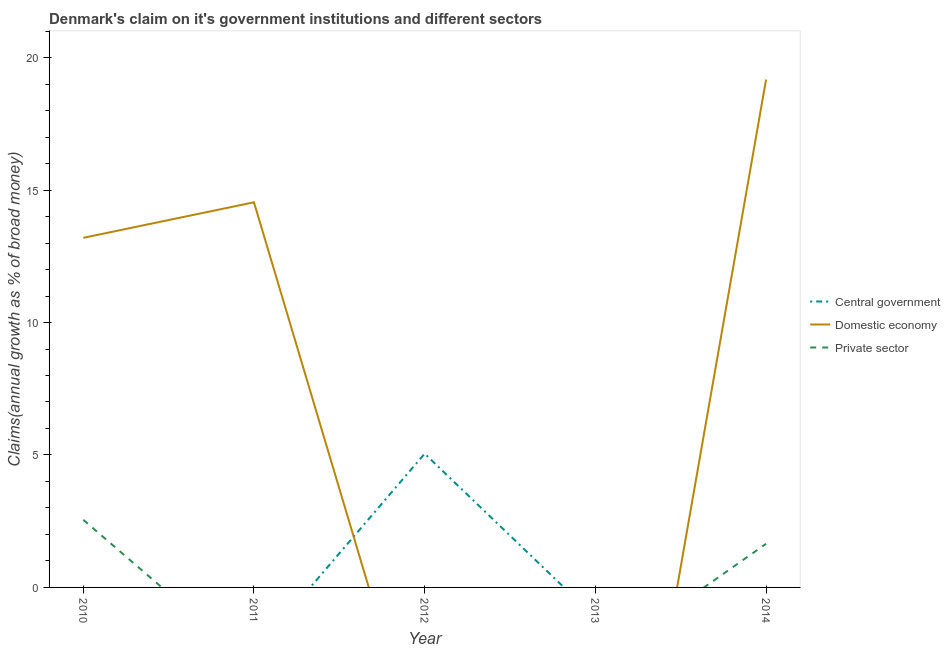How many different coloured lines are there?
Offer a very short reply. 3. Does the line corresponding to percentage of claim on the domestic economy intersect with the line corresponding to percentage of claim on the private sector?
Make the answer very short. Yes. Is the number of lines equal to the number of legend labels?
Your answer should be compact. No. Across all years, what is the maximum percentage of claim on the domestic economy?
Your answer should be compact. 19.17. Across all years, what is the minimum percentage of claim on the central government?
Provide a succinct answer. 0. What is the total percentage of claim on the domestic economy in the graph?
Your response must be concise. 46.91. What is the difference between the percentage of claim on the domestic economy in 2010 and that in 2011?
Provide a short and direct response. -1.34. What is the average percentage of claim on the central government per year?
Offer a terse response. 1.01. In the year 2014, what is the difference between the percentage of claim on the private sector and percentage of claim on the domestic economy?
Ensure brevity in your answer.  -17.53. What is the ratio of the percentage of claim on the domestic economy in 2011 to that in 2014?
Make the answer very short. 0.76. What is the difference between the highest and the second highest percentage of claim on the domestic economy?
Ensure brevity in your answer.  4.63. What is the difference between the highest and the lowest percentage of claim on the central government?
Ensure brevity in your answer.  5.05. Is it the case that in every year, the sum of the percentage of claim on the central government and percentage of claim on the domestic economy is greater than the percentage of claim on the private sector?
Your answer should be very brief. No. Is the percentage of claim on the private sector strictly greater than the percentage of claim on the central government over the years?
Offer a terse response. No. How many lines are there?
Your response must be concise. 3. How many years are there in the graph?
Ensure brevity in your answer.  5. What is the difference between two consecutive major ticks on the Y-axis?
Ensure brevity in your answer.  5. Are the values on the major ticks of Y-axis written in scientific E-notation?
Provide a succinct answer. No. Does the graph contain grids?
Offer a terse response. No. How are the legend labels stacked?
Offer a terse response. Vertical. What is the title of the graph?
Provide a succinct answer. Denmark's claim on it's government institutions and different sectors. What is the label or title of the Y-axis?
Your answer should be very brief. Claims(annual growth as % of broad money). What is the Claims(annual growth as % of broad money) of Domestic economy in 2010?
Your answer should be compact. 13.2. What is the Claims(annual growth as % of broad money) in Private sector in 2010?
Your answer should be very brief. 2.55. What is the Claims(annual growth as % of broad money) in Domestic economy in 2011?
Give a very brief answer. 14.54. What is the Claims(annual growth as % of broad money) of Central government in 2012?
Ensure brevity in your answer.  5.05. What is the Claims(annual growth as % of broad money) of Domestic economy in 2012?
Offer a terse response. 0. What is the Claims(annual growth as % of broad money) of Central government in 2013?
Make the answer very short. 0. What is the Claims(annual growth as % of broad money) of Domestic economy in 2013?
Keep it short and to the point. 0. What is the Claims(annual growth as % of broad money) of Private sector in 2013?
Make the answer very short. 0. What is the Claims(annual growth as % of broad money) of Domestic economy in 2014?
Offer a terse response. 19.17. What is the Claims(annual growth as % of broad money) in Private sector in 2014?
Give a very brief answer. 1.65. Across all years, what is the maximum Claims(annual growth as % of broad money) in Central government?
Your answer should be very brief. 5.05. Across all years, what is the maximum Claims(annual growth as % of broad money) in Domestic economy?
Offer a very short reply. 19.17. Across all years, what is the maximum Claims(annual growth as % of broad money) of Private sector?
Your answer should be very brief. 2.55. Across all years, what is the minimum Claims(annual growth as % of broad money) of Domestic economy?
Give a very brief answer. 0. Across all years, what is the minimum Claims(annual growth as % of broad money) in Private sector?
Make the answer very short. 0. What is the total Claims(annual growth as % of broad money) in Central government in the graph?
Provide a succinct answer. 5.05. What is the total Claims(annual growth as % of broad money) in Domestic economy in the graph?
Your answer should be compact. 46.91. What is the total Claims(annual growth as % of broad money) of Private sector in the graph?
Offer a very short reply. 4.2. What is the difference between the Claims(annual growth as % of broad money) of Domestic economy in 2010 and that in 2011?
Provide a succinct answer. -1.34. What is the difference between the Claims(annual growth as % of broad money) in Domestic economy in 2010 and that in 2014?
Offer a very short reply. -5.98. What is the difference between the Claims(annual growth as % of broad money) in Private sector in 2010 and that in 2014?
Your answer should be compact. 0.91. What is the difference between the Claims(annual growth as % of broad money) in Domestic economy in 2011 and that in 2014?
Give a very brief answer. -4.63. What is the difference between the Claims(annual growth as % of broad money) in Domestic economy in 2010 and the Claims(annual growth as % of broad money) in Private sector in 2014?
Provide a succinct answer. 11.55. What is the difference between the Claims(annual growth as % of broad money) of Domestic economy in 2011 and the Claims(annual growth as % of broad money) of Private sector in 2014?
Give a very brief answer. 12.89. What is the difference between the Claims(annual growth as % of broad money) in Central government in 2012 and the Claims(annual growth as % of broad money) in Domestic economy in 2014?
Your answer should be very brief. -14.12. What is the difference between the Claims(annual growth as % of broad money) of Central government in 2012 and the Claims(annual growth as % of broad money) of Private sector in 2014?
Offer a terse response. 3.4. What is the average Claims(annual growth as % of broad money) of Central government per year?
Provide a short and direct response. 1.01. What is the average Claims(annual growth as % of broad money) in Domestic economy per year?
Your response must be concise. 9.38. What is the average Claims(annual growth as % of broad money) in Private sector per year?
Your answer should be compact. 0.84. In the year 2010, what is the difference between the Claims(annual growth as % of broad money) of Domestic economy and Claims(annual growth as % of broad money) of Private sector?
Your response must be concise. 10.65. In the year 2014, what is the difference between the Claims(annual growth as % of broad money) of Domestic economy and Claims(annual growth as % of broad money) of Private sector?
Your response must be concise. 17.53. What is the ratio of the Claims(annual growth as % of broad money) in Domestic economy in 2010 to that in 2011?
Provide a short and direct response. 0.91. What is the ratio of the Claims(annual growth as % of broad money) of Domestic economy in 2010 to that in 2014?
Provide a succinct answer. 0.69. What is the ratio of the Claims(annual growth as % of broad money) of Private sector in 2010 to that in 2014?
Your answer should be compact. 1.55. What is the ratio of the Claims(annual growth as % of broad money) in Domestic economy in 2011 to that in 2014?
Make the answer very short. 0.76. What is the difference between the highest and the second highest Claims(annual growth as % of broad money) in Domestic economy?
Ensure brevity in your answer.  4.63. What is the difference between the highest and the lowest Claims(annual growth as % of broad money) in Central government?
Offer a terse response. 5.05. What is the difference between the highest and the lowest Claims(annual growth as % of broad money) in Domestic economy?
Offer a very short reply. 19.17. What is the difference between the highest and the lowest Claims(annual growth as % of broad money) of Private sector?
Offer a very short reply. 2.55. 